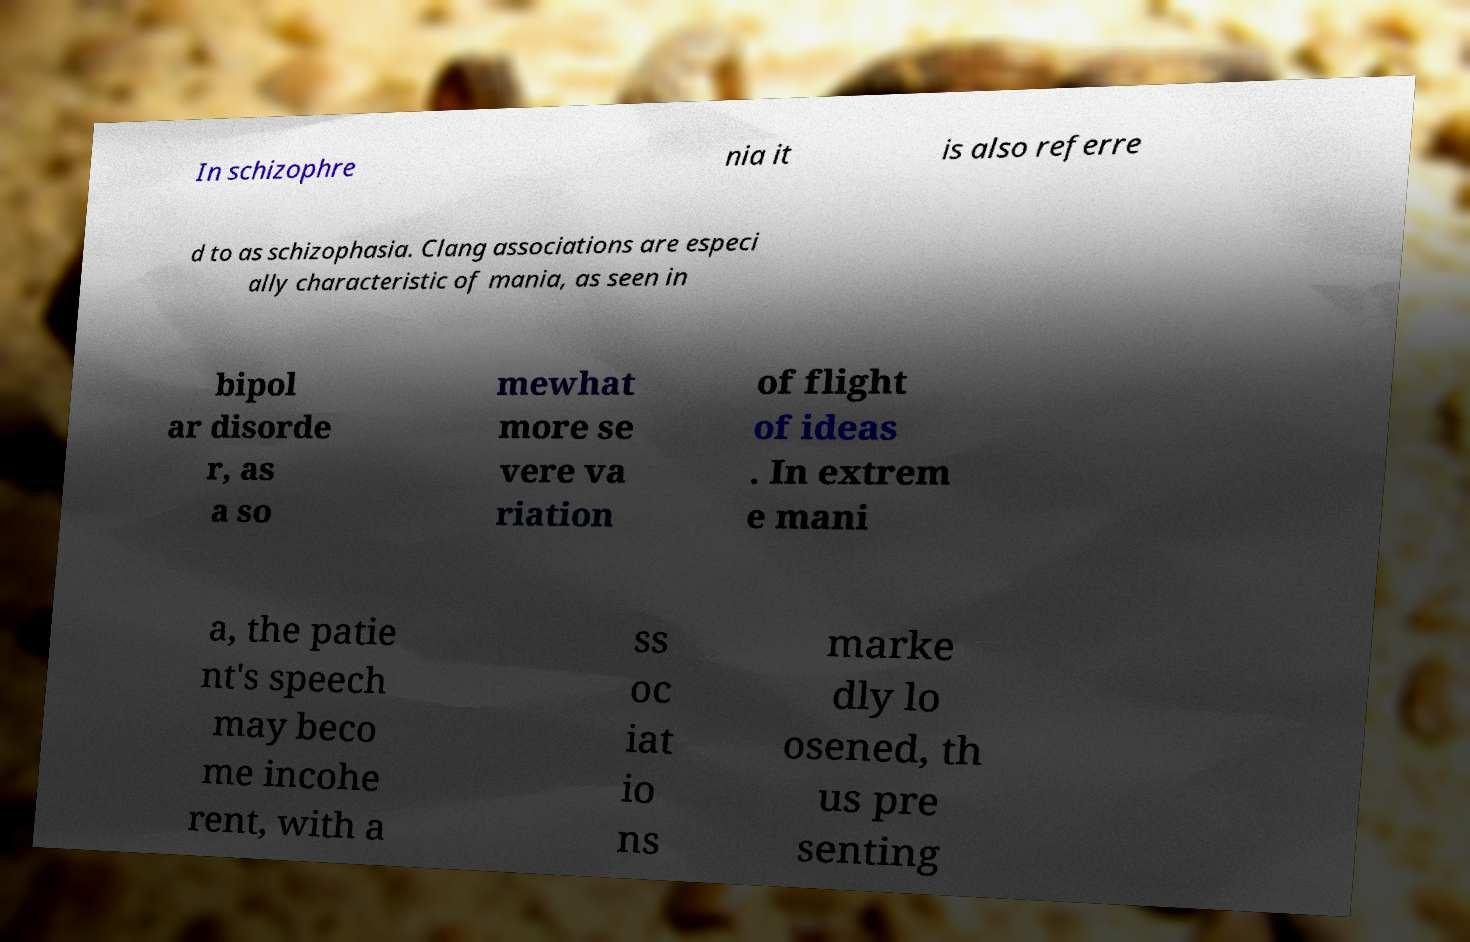Can you accurately transcribe the text from the provided image for me? In schizophre nia it is also referre d to as schizophasia. Clang associations are especi ally characteristic of mania, as seen in bipol ar disorde r, as a so mewhat more se vere va riation of flight of ideas . In extrem e mani a, the patie nt's speech may beco me incohe rent, with a ss oc iat io ns marke dly lo osened, th us pre senting 